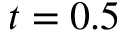Convert formula to latex. <formula><loc_0><loc_0><loc_500><loc_500>t = 0 . 5</formula> 